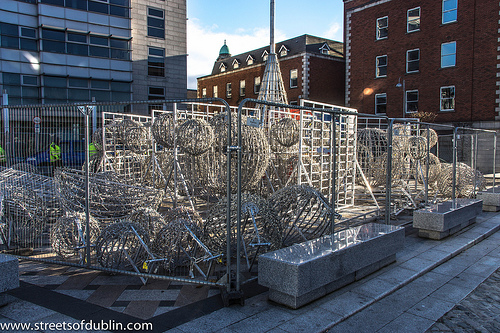<image>
Is the building behind the gate? Yes. From this viewpoint, the building is positioned behind the gate, with the gate partially or fully occluding the building. 